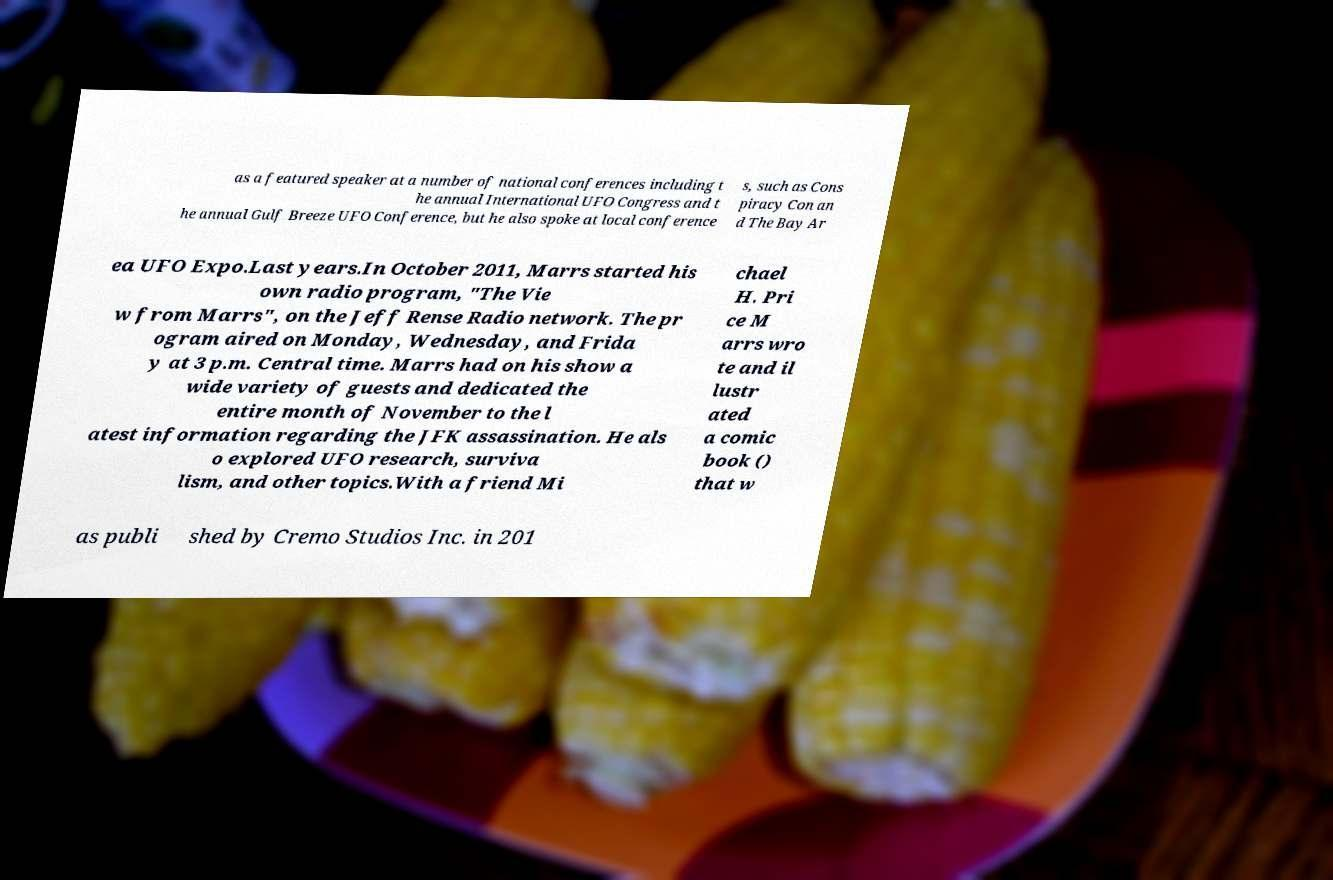What messages or text are displayed in this image? I need them in a readable, typed format. as a featured speaker at a number of national conferences including t he annual International UFO Congress and t he annual Gulf Breeze UFO Conference, but he also spoke at local conference s, such as Cons piracy Con an d The Bay Ar ea UFO Expo.Last years.In October 2011, Marrs started his own radio program, "The Vie w from Marrs", on the Jeff Rense Radio network. The pr ogram aired on Monday, Wednesday, and Frida y at 3 p.m. Central time. Marrs had on his show a wide variety of guests and dedicated the entire month of November to the l atest information regarding the JFK assassination. He als o explored UFO research, surviva lism, and other topics.With a friend Mi chael H. Pri ce M arrs wro te and il lustr ated a comic book () that w as publi shed by Cremo Studios Inc. in 201 